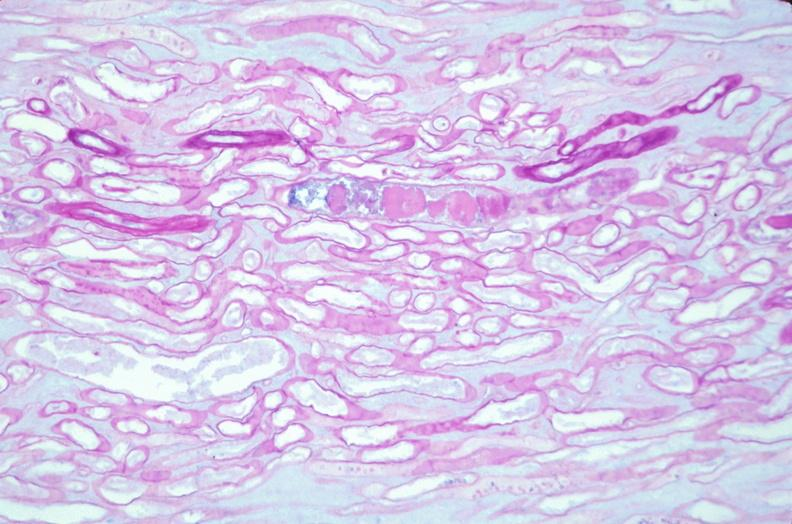why does this image show kidney, thickened and hyalinized basement membranes?
Answer the question using a single word or phrase. Due to diabetes mellitus pas 